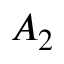Convert formula to latex. <formula><loc_0><loc_0><loc_500><loc_500>A _ { 2 }</formula> 